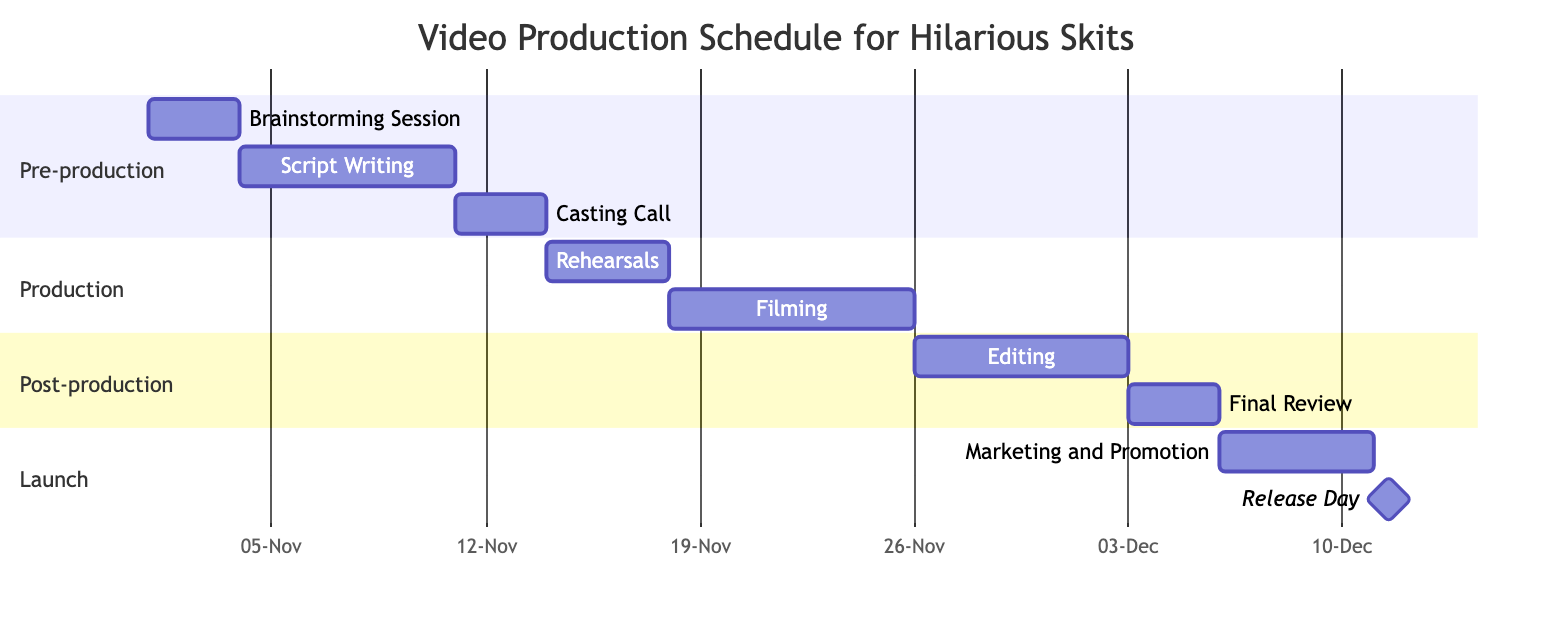What is the duration of the Script Writing task? The Script Writing task starts on November 4, 2023, and ends on November 10, 2023. The duration is calculated as the end date minus the start date, which is 7 days.
Answer: 7 days Which task immediately follows Filming? After the Filming task, the next task listed is Editing. This can be identified by looking at the schedule sequence, where Editing is positioned right after Filming.
Answer: Editing How many days are allocated for the Casting Call? The Casting Call task runs from November 11 to November 13, 2023. The duration is calculated as the end date minus the start date, resulting in 3 days.
Answer: 3 days What is the total number of tasks in the diagram? By counting each task listed under the various sections (Pre-production, Production, Post-production, Launch), we see there are a total of 8 tasks in the schedule.
Answer: 8 tasks Which task is scheduled to take place on December 11, 2023? The task that occurs on December 11, 2023, is the Release Day, which is explicitly marked for that date in the schedule.
Answer: Release Day What is the first task in the Pre-production section? The first task in the Pre-production section is the Brainstorming Session, as it appears at the top of the list under that section in the Gantt Chart.
Answer: Brainstorming Session When does Marketing and Promotion start? Marketing and Promotion starts on December 6, 2023, which is clearly indicated as the start date for that task in the diagram.
Answer: December 6 How many days of rehearsal are scheduled? The Rehearsals are scheduled from November 14 to November 17, 2023, which totals 4 days. The duration is derived from the difference between the end and start dates.
Answer: 4 days 